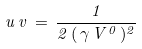<formula> <loc_0><loc_0><loc_500><loc_500>u \, v \, = \, \frac { 1 } { 2 \, ( \, \gamma \, V ^ { 0 } \, ) ^ { 2 } }</formula> 